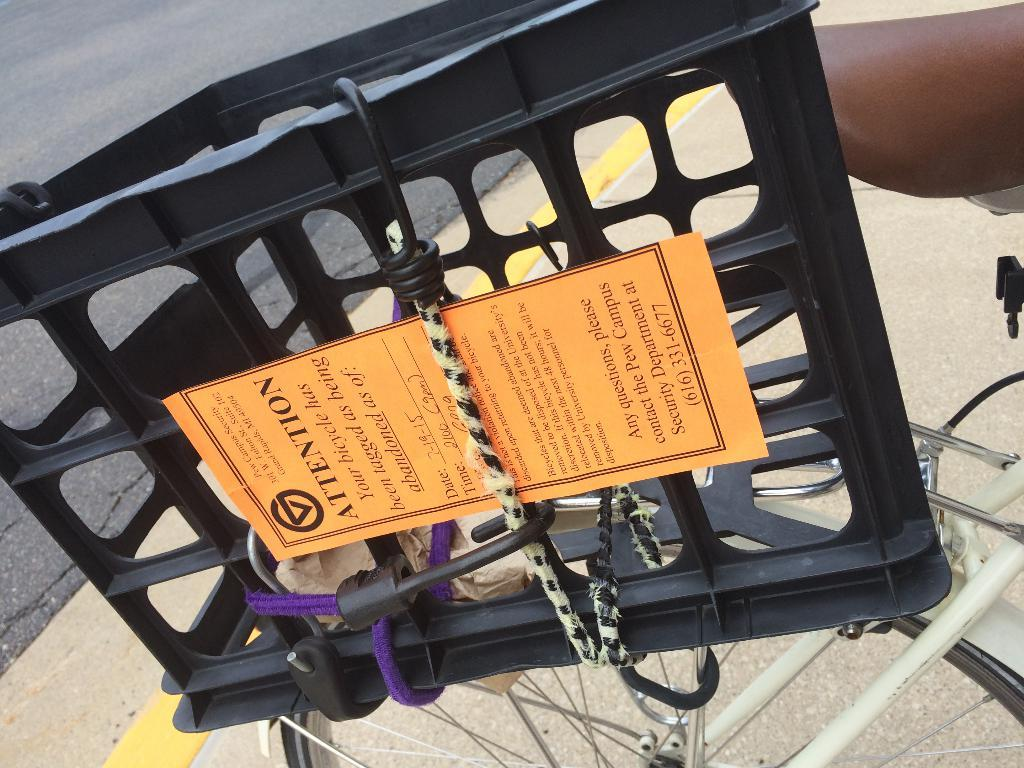What object is present on the bicycle in the image? There is a basket on the bicycle in the image. What is the purpose of the paper tied to the basket? The purpose of the paper tied to the basket is not clear from the image, but it might be a note or a message. What can be seen in the background of the image? There is a road visible in the background of the image. How many sheep are present in the image? There are no sheep present in the image. What type of comfort can be found in the basket? The image does not provide information about the comfort level of the basket. 